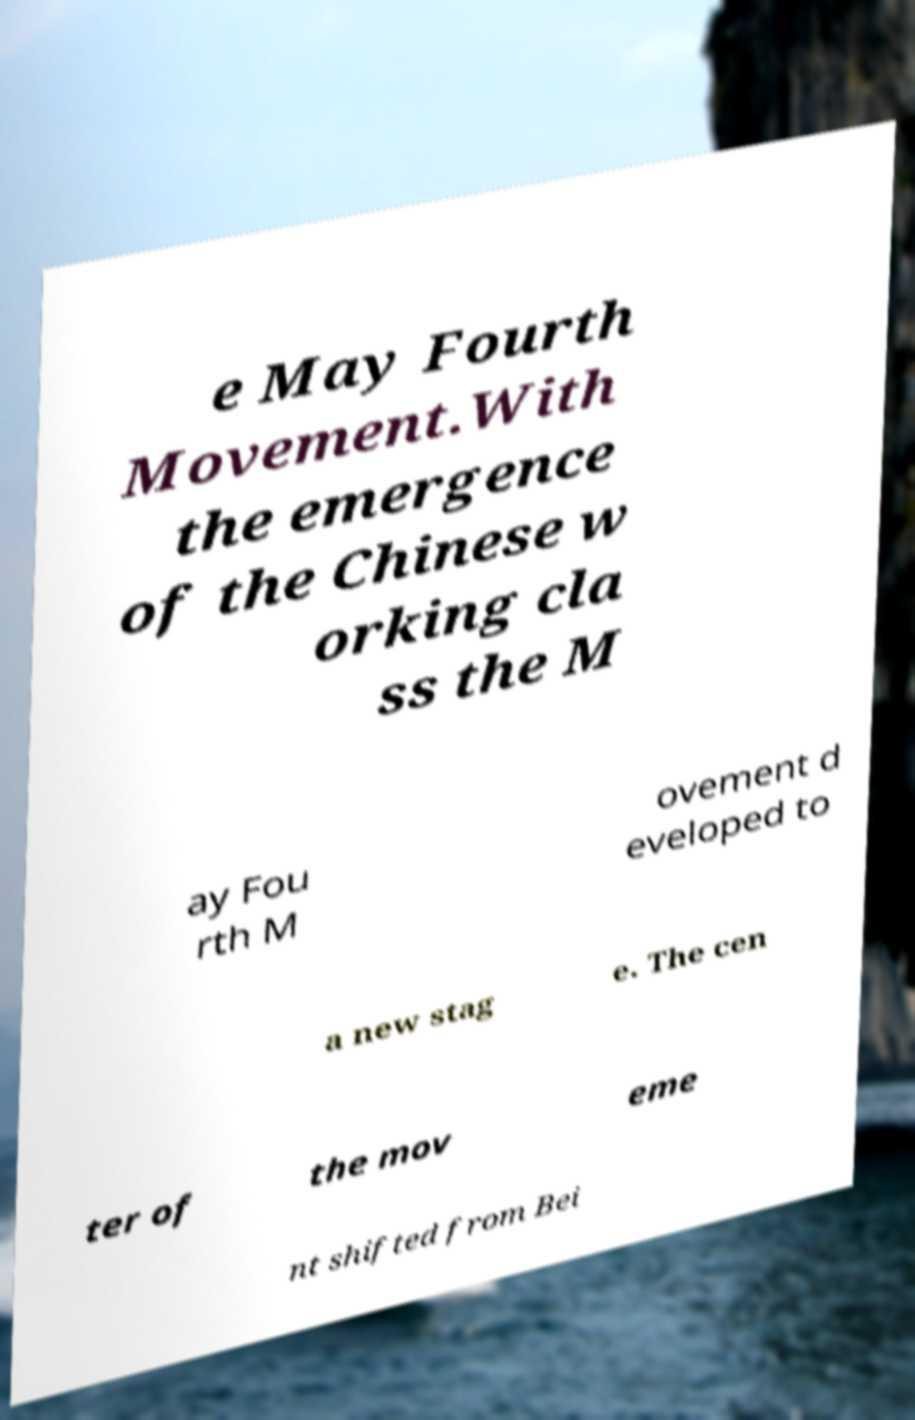I need the written content from this picture converted into text. Can you do that? e May Fourth Movement.With the emergence of the Chinese w orking cla ss the M ay Fou rth M ovement d eveloped to a new stag e. The cen ter of the mov eme nt shifted from Bei 